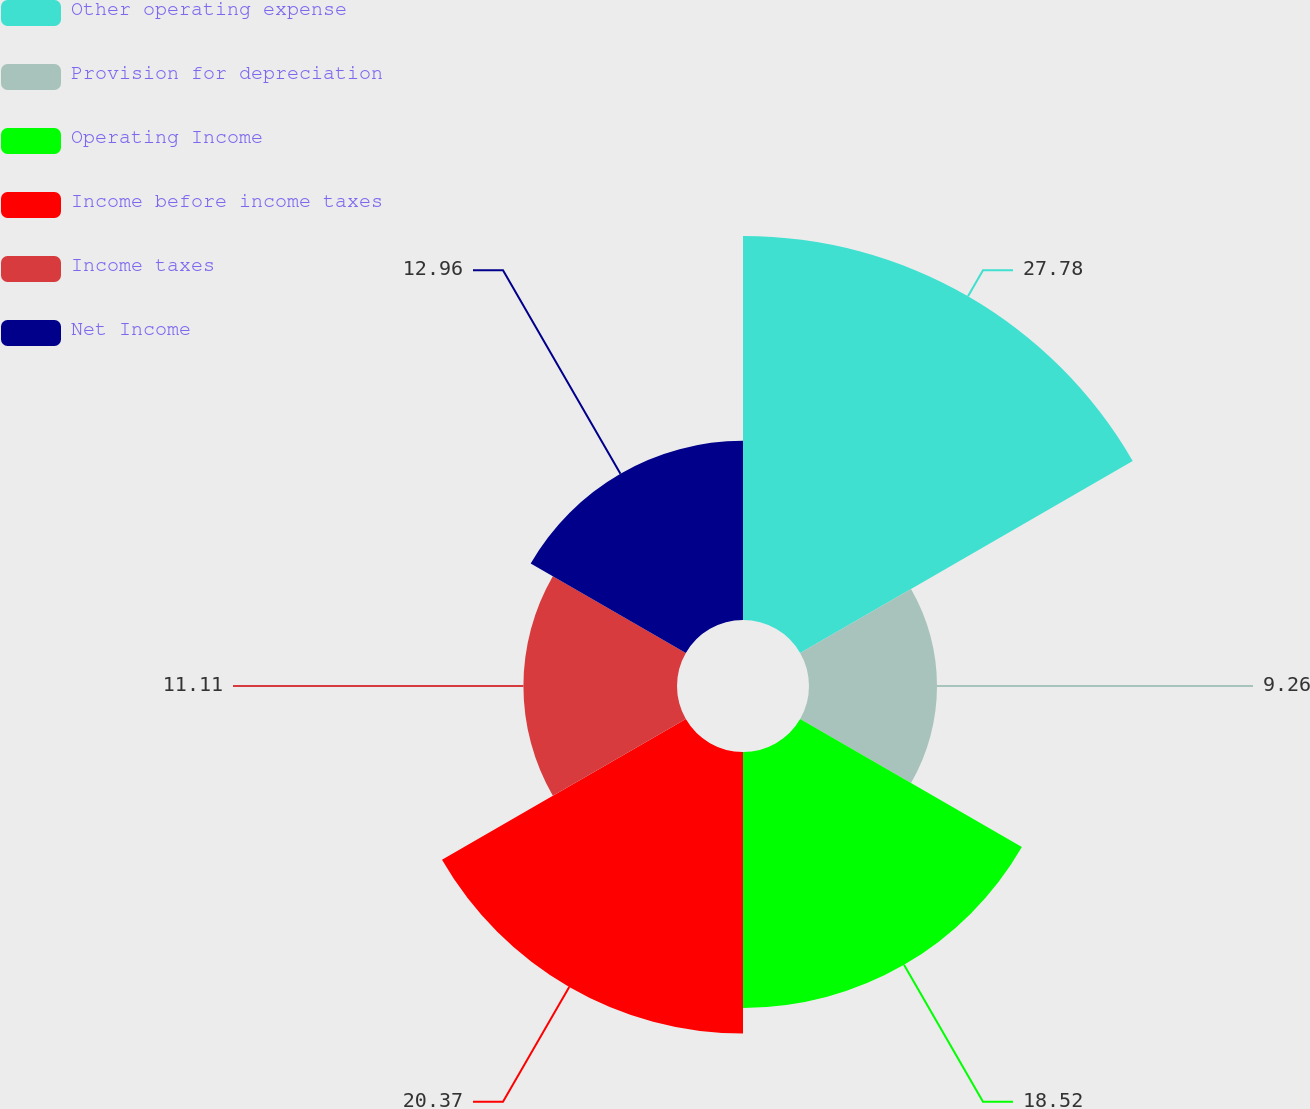Convert chart. <chart><loc_0><loc_0><loc_500><loc_500><pie_chart><fcel>Other operating expense<fcel>Provision for depreciation<fcel>Operating Income<fcel>Income before income taxes<fcel>Income taxes<fcel>Net Income<nl><fcel>27.78%<fcel>9.26%<fcel>18.52%<fcel>20.37%<fcel>11.11%<fcel>12.96%<nl></chart> 